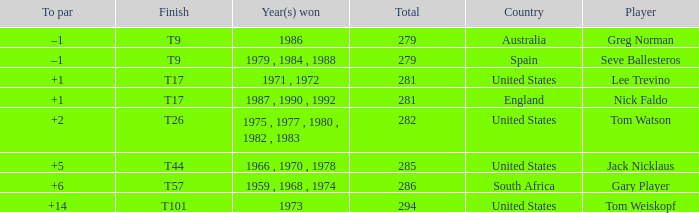Who has the highest total and a to par of +14? 294.0. 